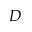<formula> <loc_0><loc_0><loc_500><loc_500>D</formula> 